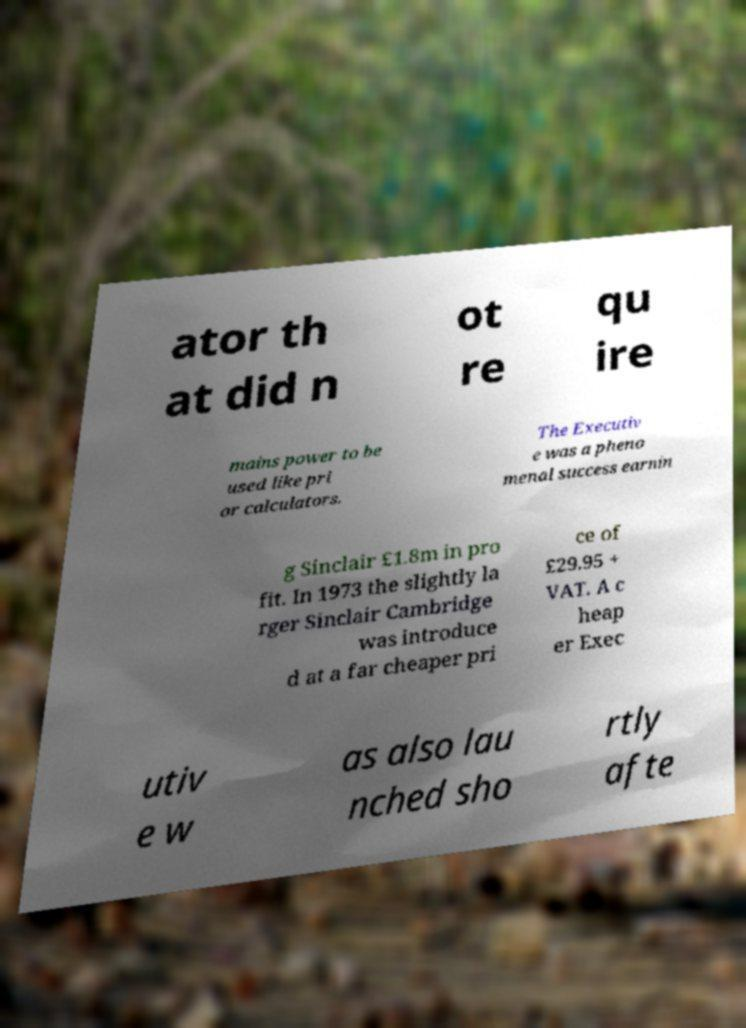There's text embedded in this image that I need extracted. Can you transcribe it verbatim? ator th at did n ot re qu ire mains power to be used like pri or calculators. The Executiv e was a pheno menal success earnin g Sinclair £1.8m in pro fit. In 1973 the slightly la rger Sinclair Cambridge was introduce d at a far cheaper pri ce of £29.95 + VAT. A c heap er Exec utiv e w as also lau nched sho rtly afte 